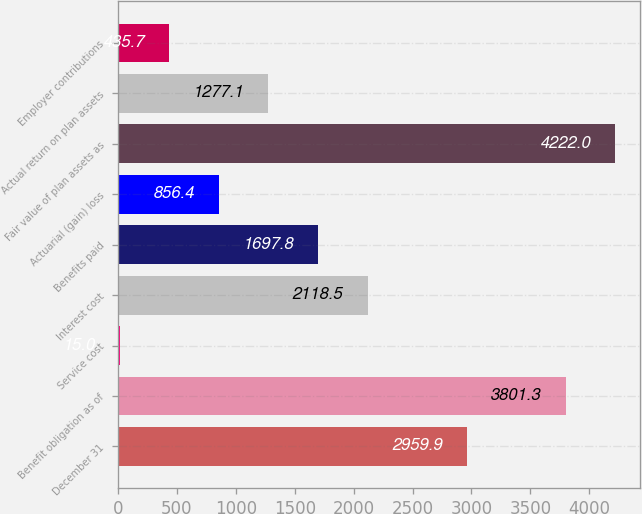Convert chart. <chart><loc_0><loc_0><loc_500><loc_500><bar_chart><fcel>December 31<fcel>Benefit obligation as of<fcel>Service cost<fcel>Interest cost<fcel>Benefits paid<fcel>Actuarial (gain) loss<fcel>Fair value of plan assets as<fcel>Actual return on plan assets<fcel>Employer contributions<nl><fcel>2959.9<fcel>3801.3<fcel>15<fcel>2118.5<fcel>1697.8<fcel>856.4<fcel>4222<fcel>1277.1<fcel>435.7<nl></chart> 